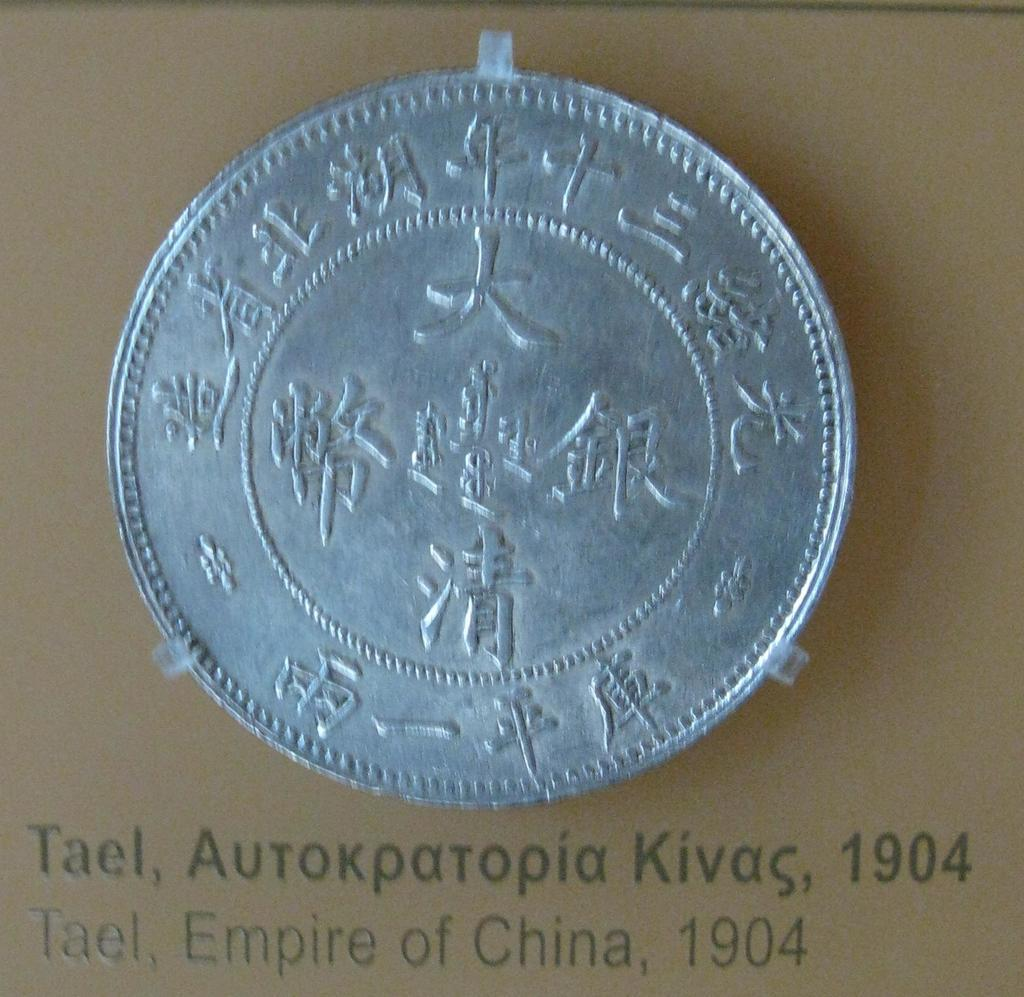<image>
Relay a brief, clear account of the picture shown. A silver coin with a year and the Empire of China written underneath it. 